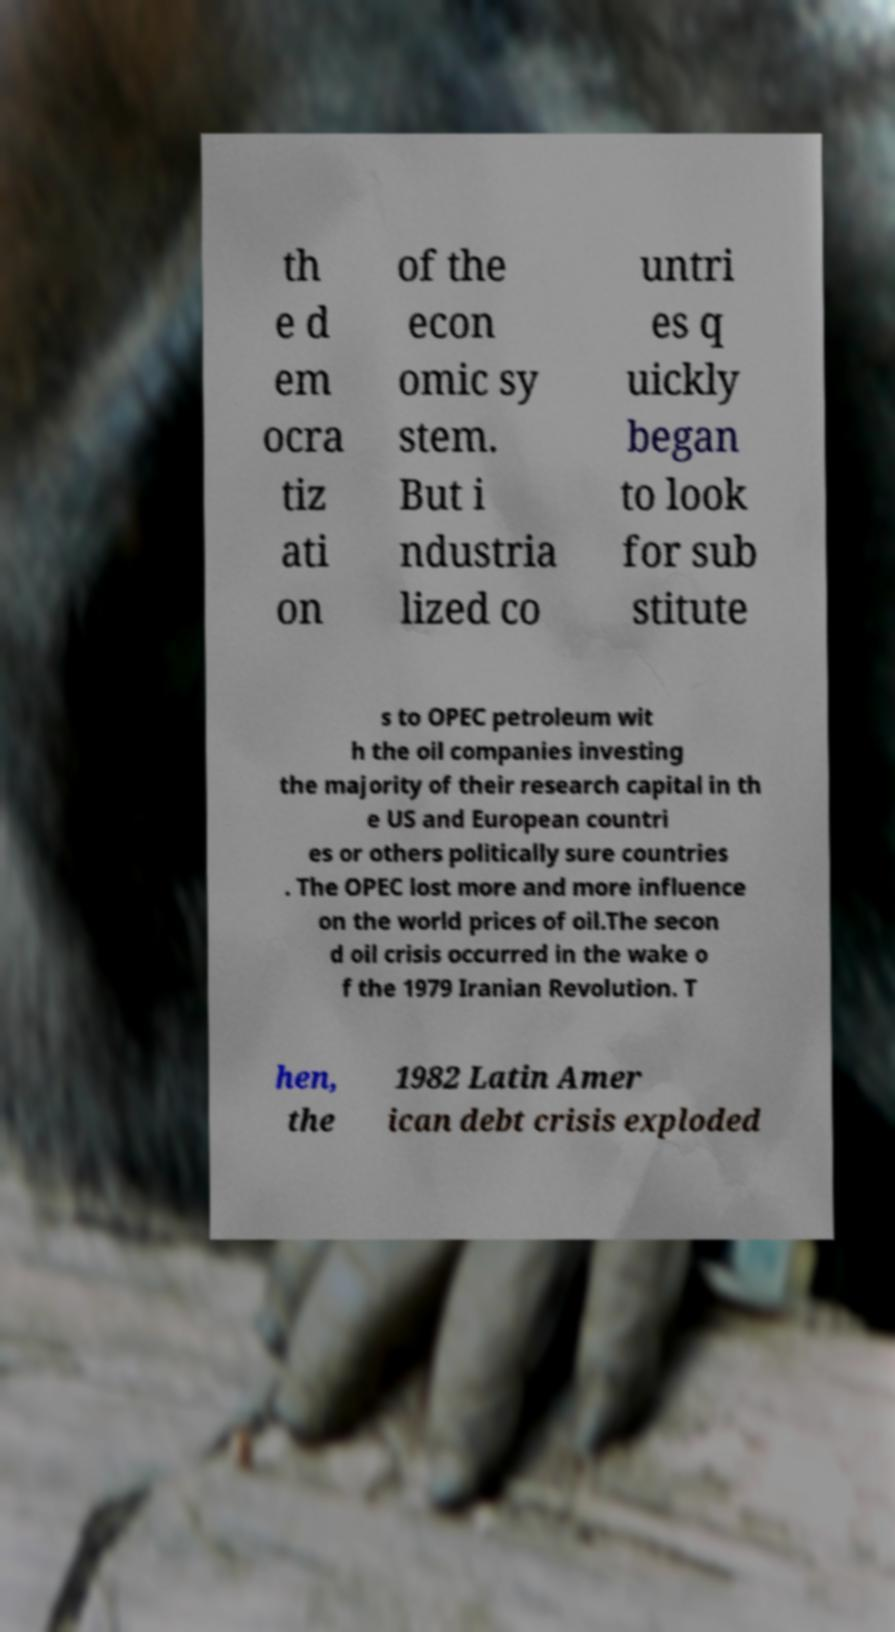Please read and relay the text visible in this image. What does it say? th e d em ocra tiz ati on of the econ omic sy stem. But i ndustria lized co untri es q uickly began to look for sub stitute s to OPEC petroleum wit h the oil companies investing the majority of their research capital in th e US and European countri es or others politically sure countries . The OPEC lost more and more influence on the world prices of oil.The secon d oil crisis occurred in the wake o f the 1979 Iranian Revolution. T hen, the 1982 Latin Amer ican debt crisis exploded 